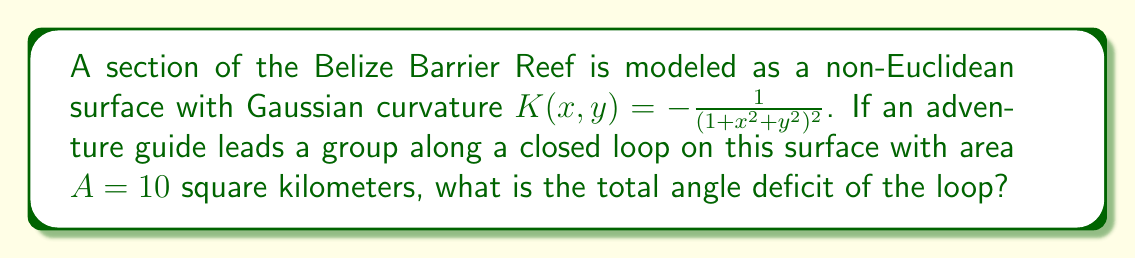Could you help me with this problem? To solve this problem, we'll use the Gauss-Bonnet theorem, which relates the Gaussian curvature of a surface to the geometry of curves on that surface.

1) The Gauss-Bonnet theorem states:

   $$\iint_D K \, dA + \oint_{\partial D} k_g \, ds + \sum_{i=1}^n \theta_i = 2\pi\chi(D)$$

   Where $K$ is the Gaussian curvature, $A$ is the area, $k_g$ is the geodesic curvature, $\theta_i$ are the exterior angles at corners, and $\chi(D)$ is the Euler characteristic of the region.

2) For a closed loop without corners on a surface, this simplifies to:

   $$\iint_D K \, dA = 2\pi - \text{(sum of interior angles)}$$

3) The left side of this equation is the integral of the Gaussian curvature over the area, which gives us the total angle deficit.

4) We're given that $K(x,y) = -\frac{1}{(1+x^2+y^2)^2}$ and $A = 10$ km².

5) The exact integral would be complex, but we can approximate it using the average value of $K$ over the region. Since $K$ is always negative and decreases as we move away from the origin, its average value over any region will be between 0 and -1.

6) Let's estimate the average value of $K$ as -0.5. Then:

   $$\text{Total angle deficit} \approx 10 \text{ km}^2 \times (-0.5 \text{ km}^{-2}) = -5 \text{ radians}$$

7) Convert to degrees:

   $$-5 \text{ radians} \times \frac{180°}{\pi} \approx -286.5°$$

This negative value indicates that the sum of the interior angles of the loop is greater than would be expected in Euclidean geometry, which is characteristic of a surface with negative curvature.
Answer: Approximately -286.5° 